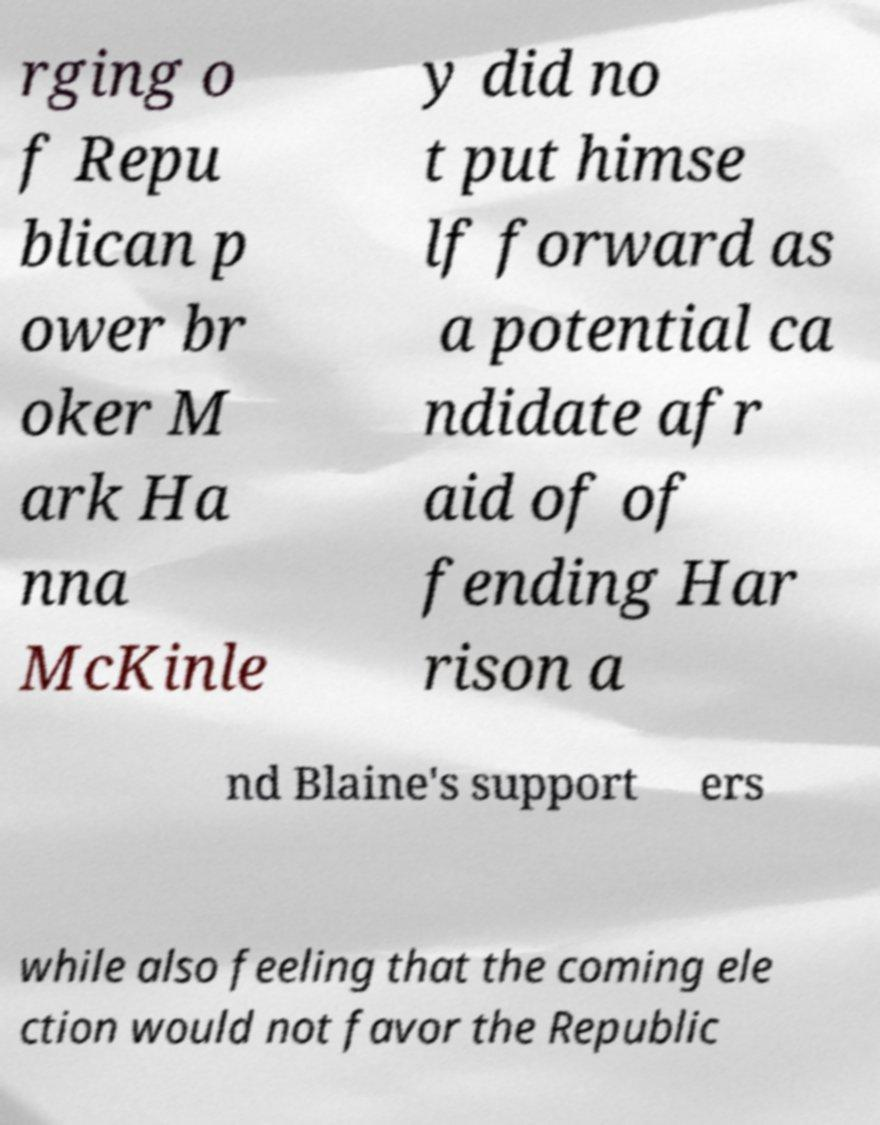Please identify and transcribe the text found in this image. rging o f Repu blican p ower br oker M ark Ha nna McKinle y did no t put himse lf forward as a potential ca ndidate afr aid of of fending Har rison a nd Blaine's support ers while also feeling that the coming ele ction would not favor the Republic 